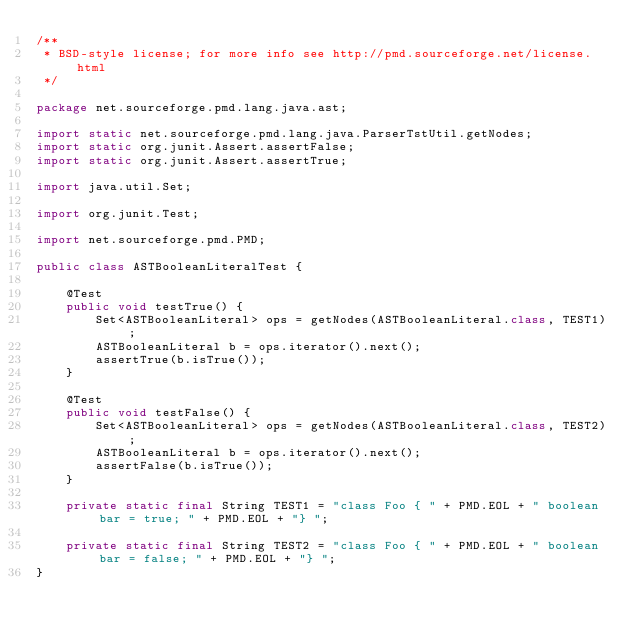<code> <loc_0><loc_0><loc_500><loc_500><_Java_>/**
 * BSD-style license; for more info see http://pmd.sourceforge.net/license.html
 */

package net.sourceforge.pmd.lang.java.ast;

import static net.sourceforge.pmd.lang.java.ParserTstUtil.getNodes;
import static org.junit.Assert.assertFalse;
import static org.junit.Assert.assertTrue;

import java.util.Set;

import org.junit.Test;

import net.sourceforge.pmd.PMD;

public class ASTBooleanLiteralTest {

    @Test
    public void testTrue() {
        Set<ASTBooleanLiteral> ops = getNodes(ASTBooleanLiteral.class, TEST1);
        ASTBooleanLiteral b = ops.iterator().next();
        assertTrue(b.isTrue());
    }

    @Test
    public void testFalse() {
        Set<ASTBooleanLiteral> ops = getNodes(ASTBooleanLiteral.class, TEST2);
        ASTBooleanLiteral b = ops.iterator().next();
        assertFalse(b.isTrue());
    }

    private static final String TEST1 = "class Foo { " + PMD.EOL + " boolean bar = true; " + PMD.EOL + "} ";

    private static final String TEST2 = "class Foo { " + PMD.EOL + " boolean bar = false; " + PMD.EOL + "} ";
}
</code> 